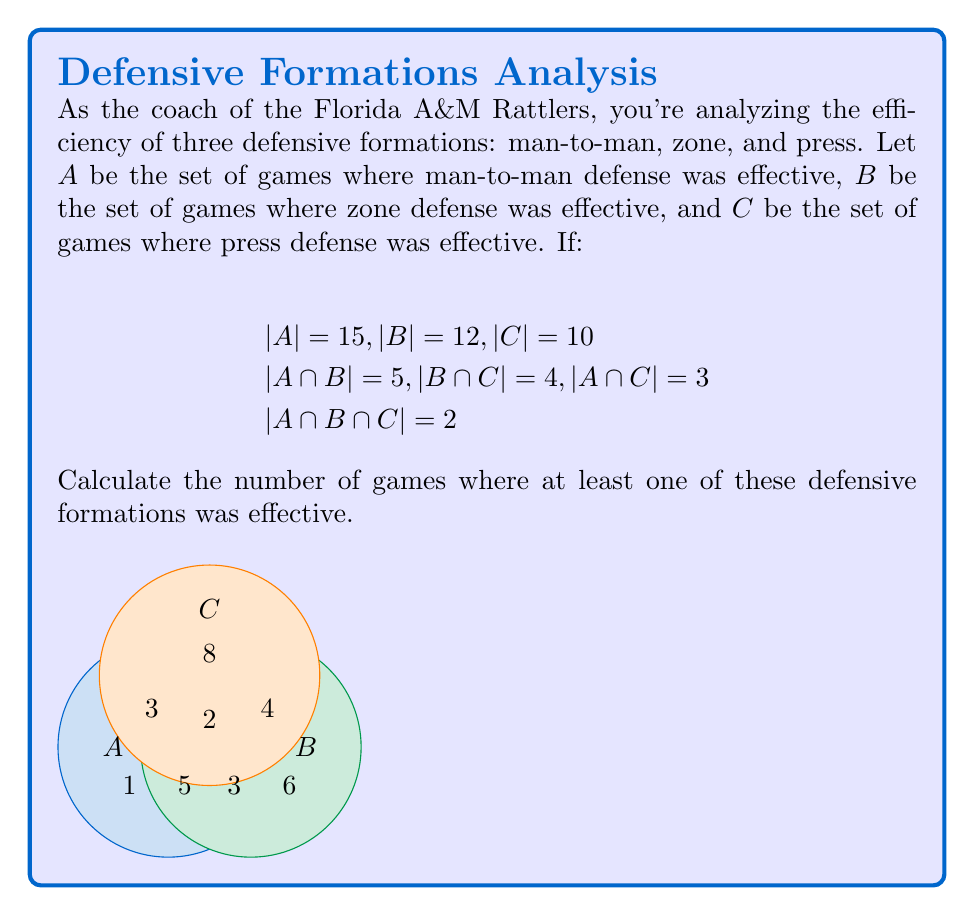Teach me how to tackle this problem. Let's approach this step-by-step using the principle of inclusion-exclusion:

1) First, we need to find $|A \cup B \cup C|$, which represents the number of games where at least one defensive formation was effective.

2) The principle of inclusion-exclusion states:

   $$|A \cup B \cup C| = |A| + |B| + |C| - |A \cap B| - |B \cap C| - |A \cap C| + |A \cap B \cap C|$$

3) We're given:
   $$|A| = 15, |B| = 12, |C| = 10$$
   $$|A \cap B| = 5, |B \cap C| = 4, |A \cap C| = 3$$
   $$|A \cap B \cap C| = 2$$

4) Let's substitute these values into our equation:

   $$|A \cup B \cup C| = 15 + 12 + 10 - 5 - 4 - 3 + 2$$

5) Now we can calculate:

   $$|A \cup B \cup C| = 37 - 12 + 2 = 27$$

Therefore, there were 27 games where at least one of these defensive formations was effective.
Answer: 27 games 